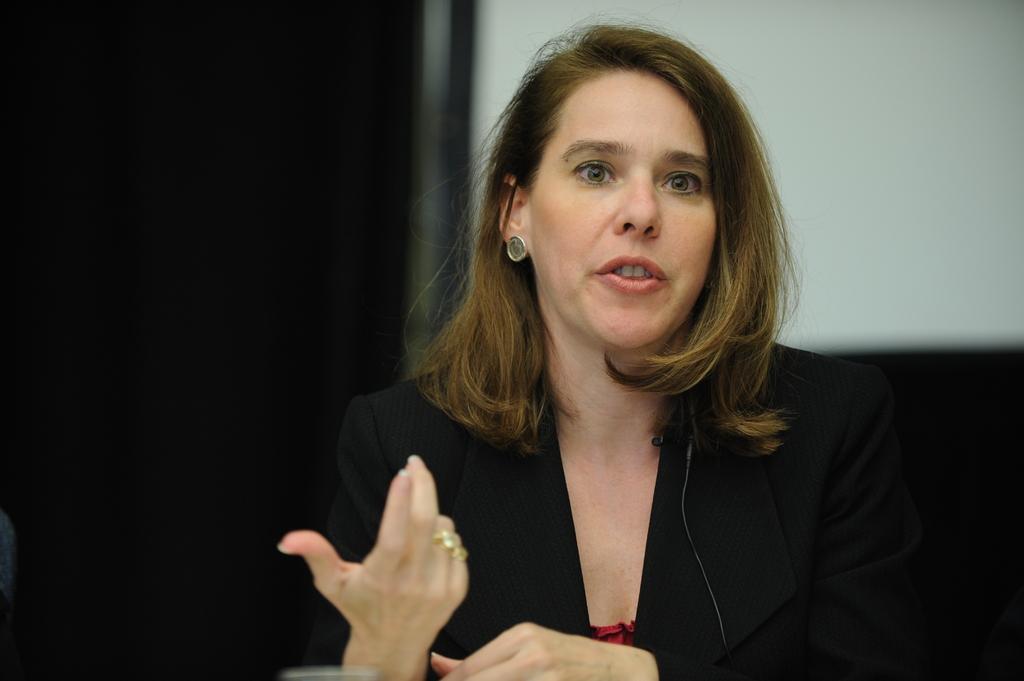In one or two sentences, can you explain what this image depicts? In this picture we can see the women wearing a black suit, standing in the front and speaking something. Behind there is a white wall and dark background. 